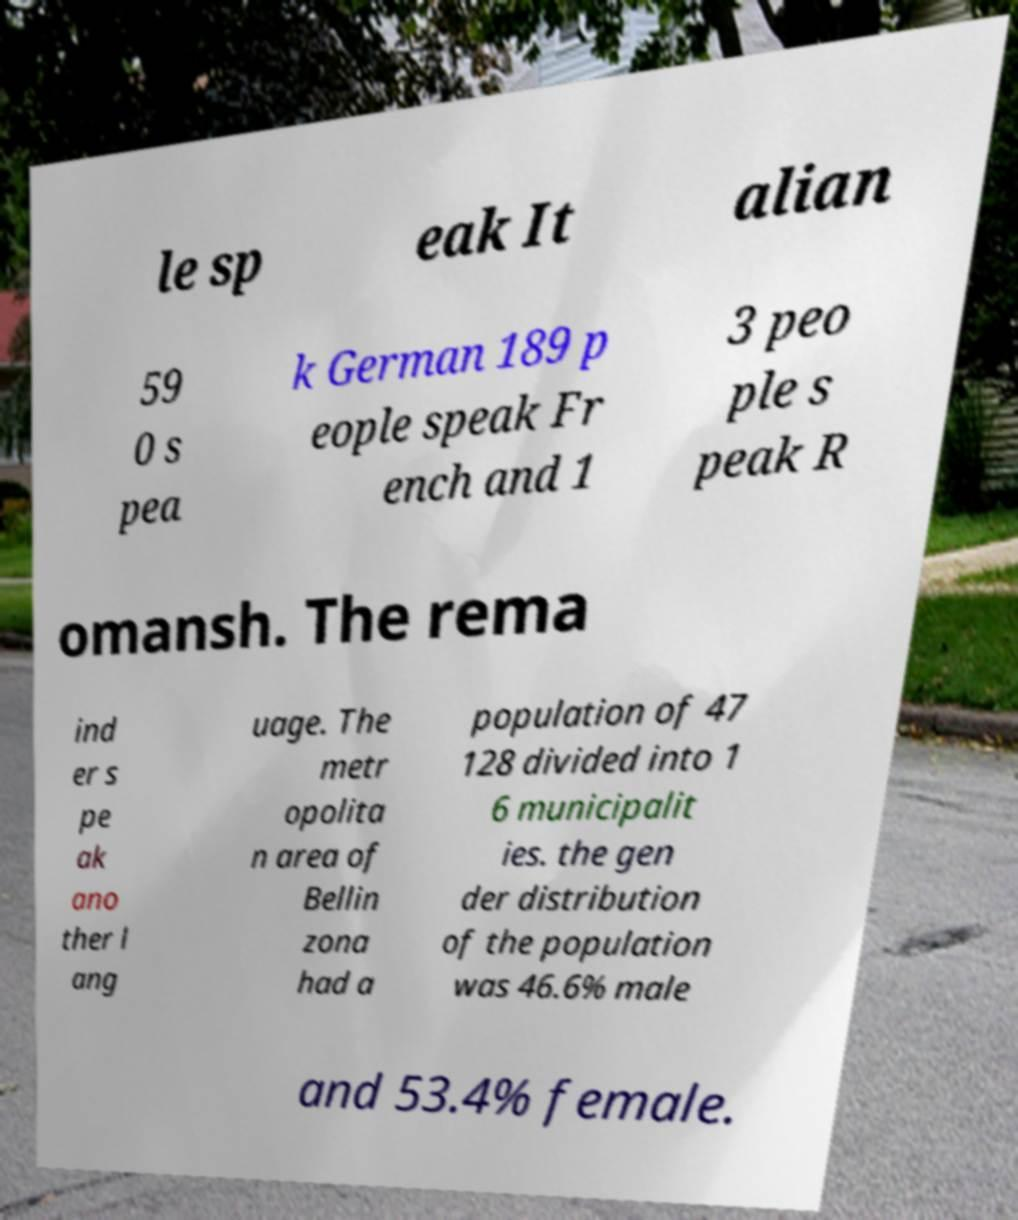I need the written content from this picture converted into text. Can you do that? le sp eak It alian 59 0 s pea k German 189 p eople speak Fr ench and 1 3 peo ple s peak R omansh. The rema ind er s pe ak ano ther l ang uage. The metr opolita n area of Bellin zona had a population of 47 128 divided into 1 6 municipalit ies. the gen der distribution of the population was 46.6% male and 53.4% female. 